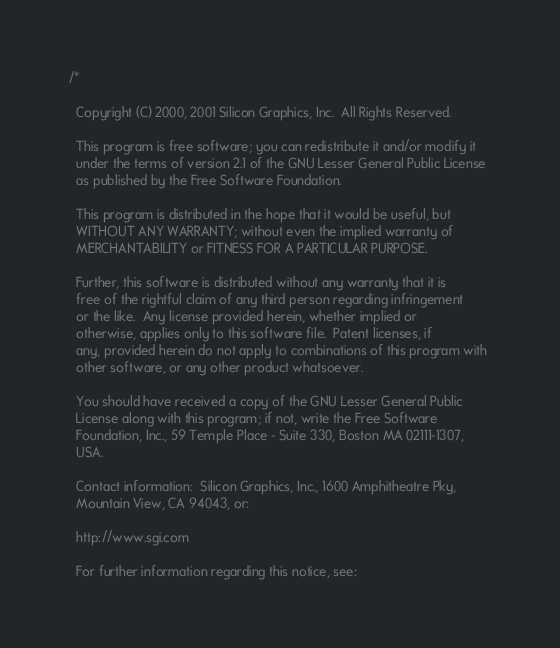Convert code to text. <code><loc_0><loc_0><loc_500><loc_500><_C_>/*

  Copyright (C) 2000, 2001 Silicon Graphics, Inc.  All Rights Reserved.

  This program is free software; you can redistribute it and/or modify it
  under the terms of version 2.1 of the GNU Lesser General Public License 
  as published by the Free Software Foundation.

  This program is distributed in the hope that it would be useful, but
  WITHOUT ANY WARRANTY; without even the implied warranty of
  MERCHANTABILITY or FITNESS FOR A PARTICULAR PURPOSE.  

  Further, this software is distributed without any warranty that it is
  free of the rightful claim of any third person regarding infringement 
  or the like.  Any license provided herein, whether implied or 
  otherwise, applies only to this software file.  Patent licenses, if
  any, provided herein do not apply to combinations of this program with 
  other software, or any other product whatsoever.  

  You should have received a copy of the GNU Lesser General Public 
  License along with this program; if not, write the Free Software 
  Foundation, Inc., 59 Temple Place - Suite 330, Boston MA 02111-1307, 
  USA.

  Contact information:  Silicon Graphics, Inc., 1600 Amphitheatre Pky,
  Mountain View, CA 94043, or:

  http://www.sgi.com

  For further information regarding this notice, see:
</code> 